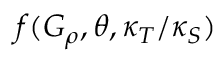<formula> <loc_0><loc_0><loc_500><loc_500>f ( G _ { \rho } , \theta , \kappa _ { T } / \kappa _ { S } )</formula> 